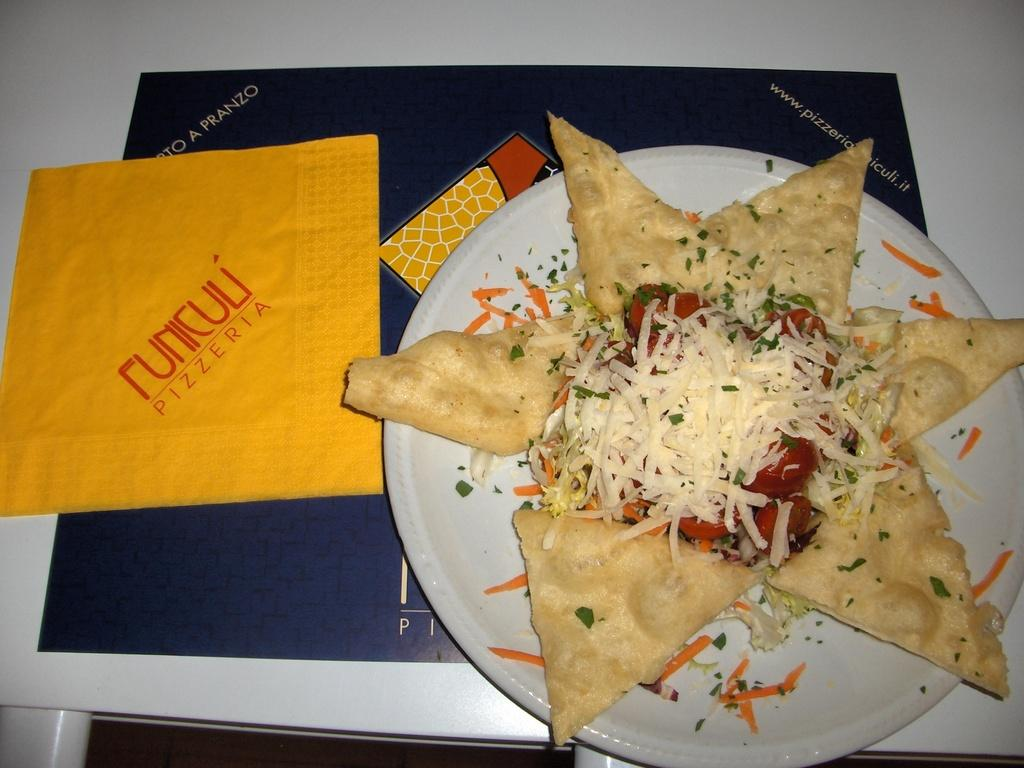<image>
Describe the image concisely. A plate of cheese, tomato sauce, and tortillas served at Funiculi Pizzeria. 